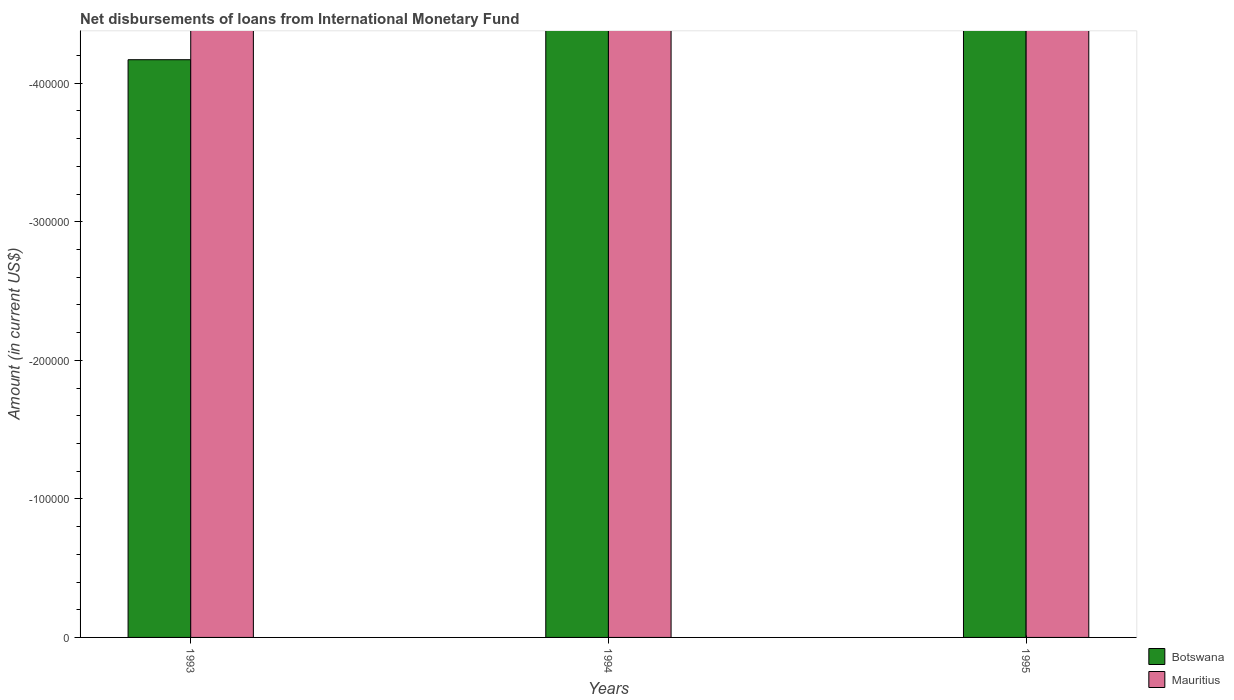How many different coloured bars are there?
Keep it short and to the point. 0. Are the number of bars per tick equal to the number of legend labels?
Make the answer very short. No. How many bars are there on the 3rd tick from the left?
Offer a terse response. 0. How many bars are there on the 2nd tick from the right?
Make the answer very short. 0. What is the label of the 2nd group of bars from the left?
Keep it short and to the point. 1994. In how many cases, is the number of bars for a given year not equal to the number of legend labels?
Your answer should be compact. 3. What is the total amount of loans disbursed in Botswana in the graph?
Keep it short and to the point. 0. What is the average amount of loans disbursed in Mauritius per year?
Your response must be concise. 0. What is the difference between two consecutive major ticks on the Y-axis?
Offer a very short reply. 1.00e+05. Are the values on the major ticks of Y-axis written in scientific E-notation?
Your response must be concise. No. How many legend labels are there?
Your response must be concise. 2. How are the legend labels stacked?
Give a very brief answer. Vertical. What is the title of the graph?
Provide a short and direct response. Net disbursements of loans from International Monetary Fund. Does "Guinea" appear as one of the legend labels in the graph?
Provide a short and direct response. No. What is the Amount (in current US$) of Botswana in 1993?
Provide a short and direct response. 0. What is the Amount (in current US$) of Mauritius in 1993?
Give a very brief answer. 0. What is the Amount (in current US$) of Botswana in 1994?
Provide a short and direct response. 0. What is the Amount (in current US$) in Mauritius in 1995?
Keep it short and to the point. 0. What is the total Amount (in current US$) of Mauritius in the graph?
Offer a terse response. 0. What is the average Amount (in current US$) in Mauritius per year?
Your response must be concise. 0. 